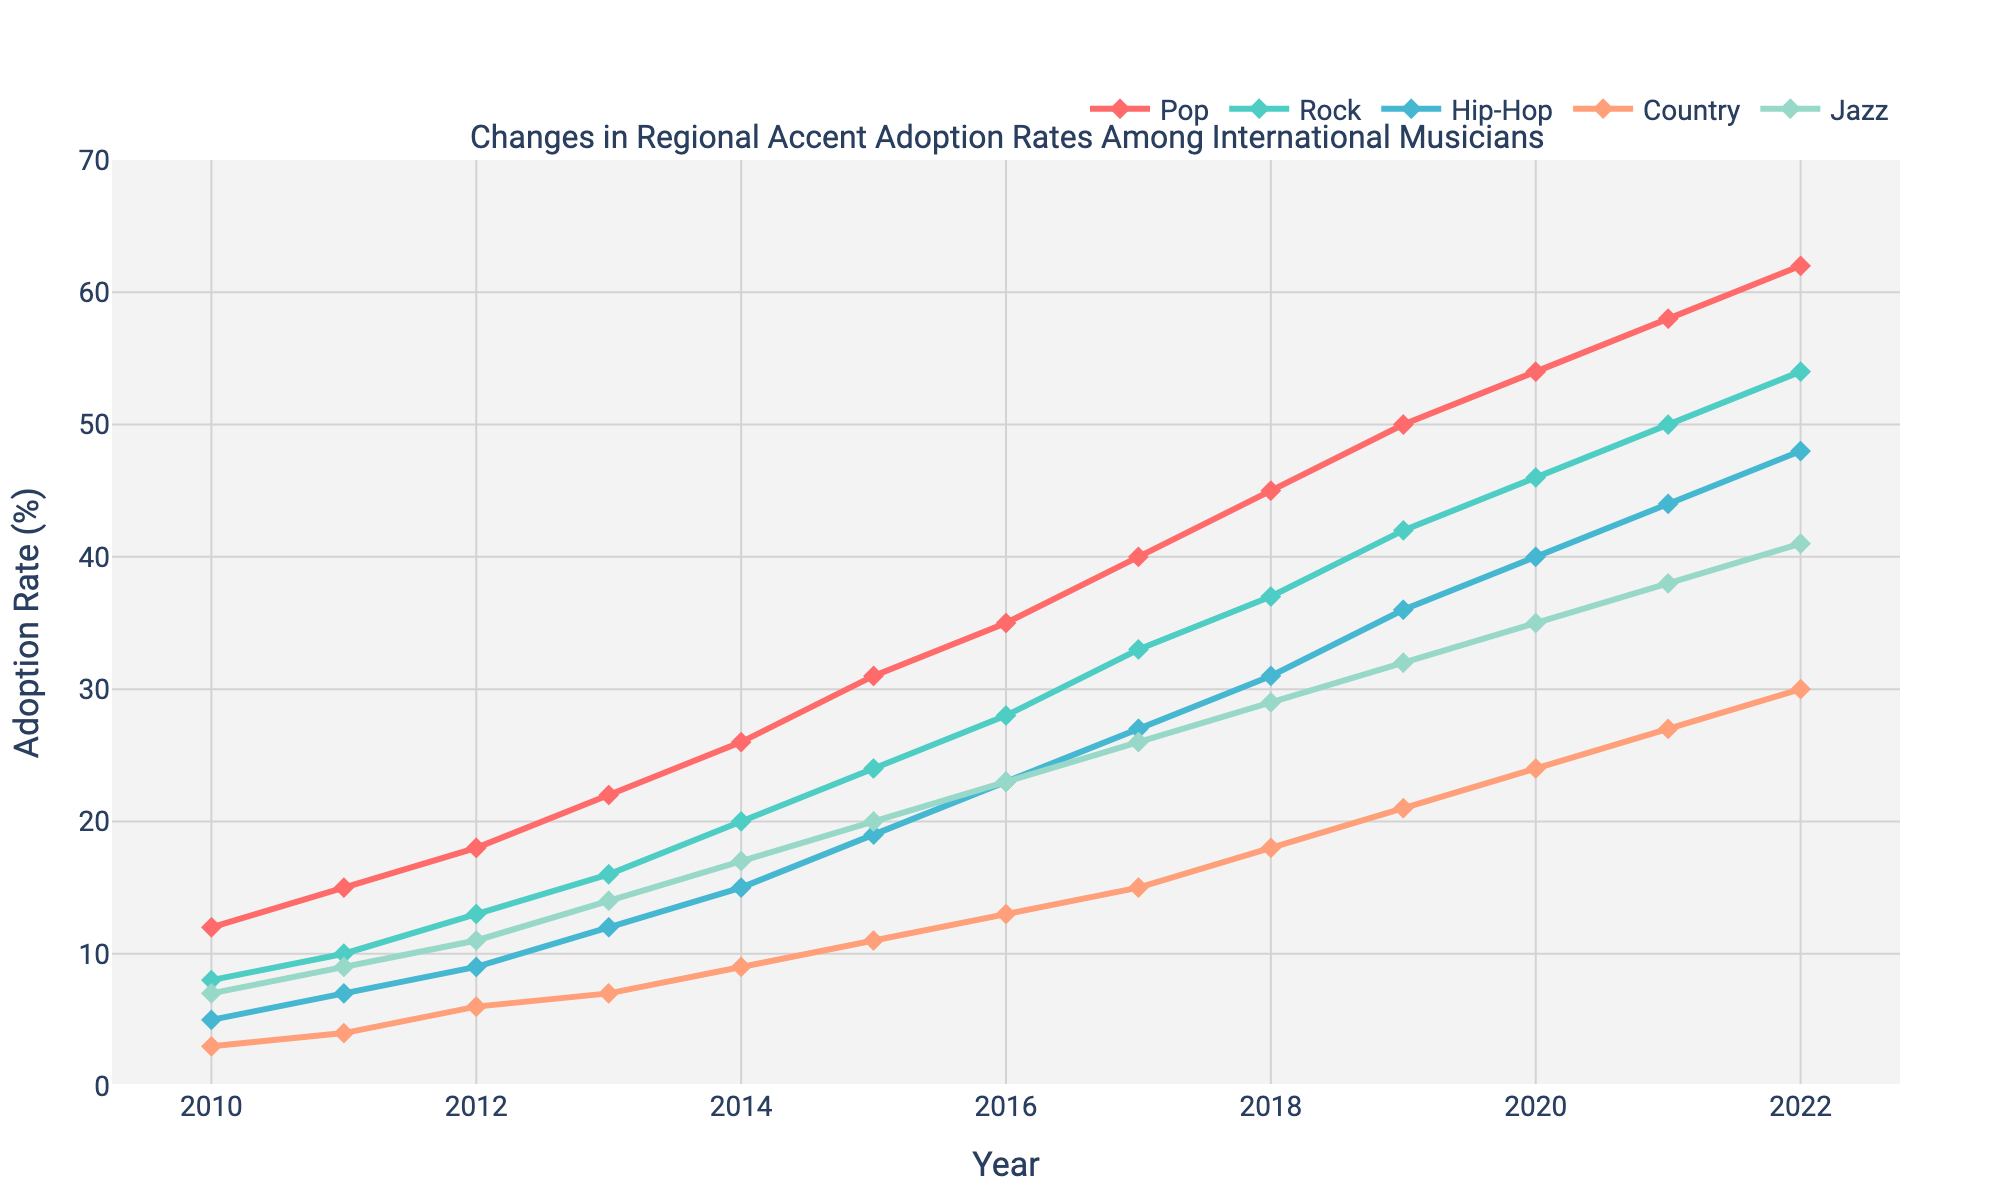What genre had the highest adoption rate in 2022? To find the genre with the highest adoption rate in 2022, look at the lines and markers’ positions along the y-axis corresponding to 2022. The point at the top is Pop.
Answer: Pop Compare the adoption rates of Rock and Jazz in 2015. Which was higher, and by how much? Compare the heights of the markers for Rock and Jazz in 2015. Rock is at 24%, and Jazz is at 20%, so Rock is higher by 4%.
Answer: Rock, by 4% What is the average adoption rate of Hip-Hop from 2010 to 2022? Add Hip-Hop's adoption rates from 2010 to 2022: (5 + 7 + 9 + 12 + 15 + 19 + 23 + 27 + 31 + 36 + 40 + 44 + 48) = 316. Divide by the total number of years (13). So, 316 / 13 = 24.31%.
Answer: 24.31% How did the adoption rate of Country music change from 2013 to 2019? Subtract the adoption rate of Country in 2013 from that of 2019: 21% - 7% = 14%.
Answer: Increased by 14% Which genre showed the most significant increase in adoption rates between 2012 and 2014? Calculate the increase for each genre between 2012 and 2014: Pop (26-18=8%), Rock (20-13=7%), Hip-Hop (15-9=6%), Country (9-6=3%), Jazz (17-11=6%). Pop had the most significant increase of 8%.
Answer: Pop, by 8% In which year did Jazz equal the Pop adoption rate in 2011? Look at the y-values for both Jazz and Pop lines to see if they intersect in a specific year. They do not intersect in any year according to the data.
Answer: They never equaled Which genre had the lowest adoption rate in 2016? Identify the lowest point among the markers in 2016. Country has the lowest adoption rate at 13%.
Answer: Country What is the difference in adoption rates between Hip-Hop and Rock in 2020? Subtract the adoption rate of Rock from Hip-Hop in 2020: 40% - 46% = -6%. Hip-Hop adoption rate is 6% lower than Rock.
Answer: -6% What was the trend in the adoption rate of Jazz over the entire period? Observe the Jazz line's trajectory from 2010 to 2022. It consistently rises each year.
Answer: Increasing Compare the slopes of the adoption rate lines between Pop and Hip-Hop from 2015 to 2018. Which increased more rapidly? Calculate the slope (change in y over change in x). Pop: (45-31)/(2018-2015) = 14/3 = 4.67. Hip-Hop: (31-19)/(2018-2015) = 12/3 = 4. Pop increased more rapidly with a slope of 4.67 compared to Hip-Hop's 4.
Answer: Pop 